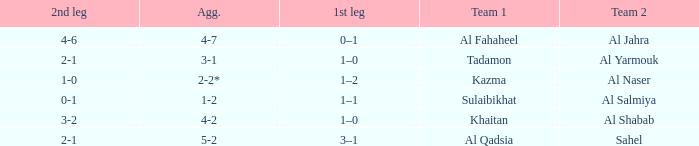What is the 1st leg of the Al Fahaheel Team 1? 0–1. 